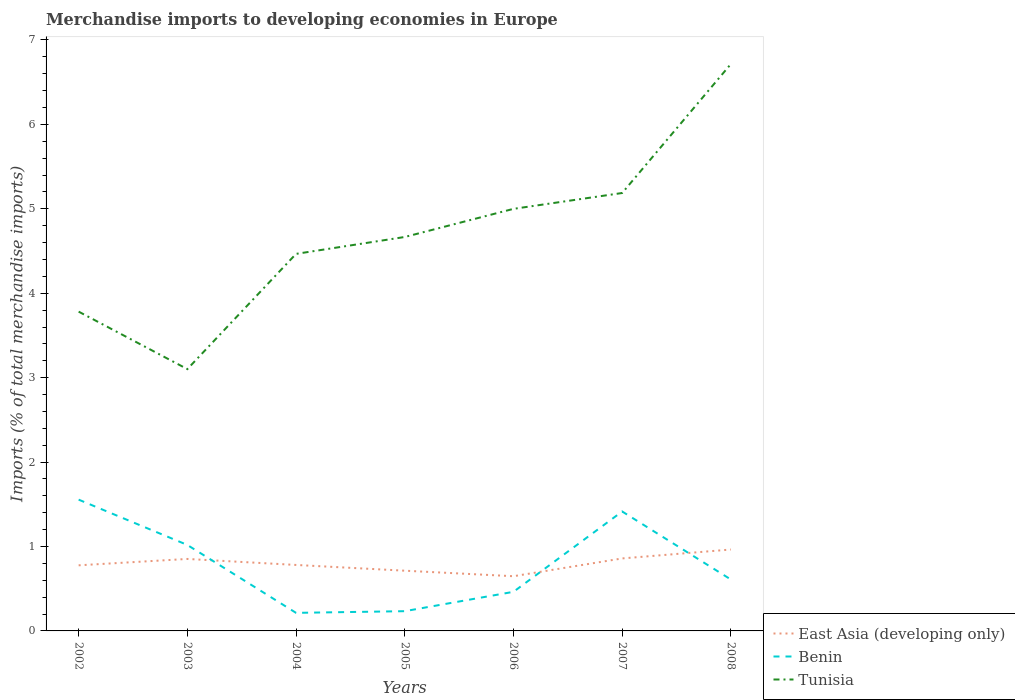How many different coloured lines are there?
Your answer should be compact. 3. Does the line corresponding to Benin intersect with the line corresponding to East Asia (developing only)?
Offer a very short reply. Yes. Is the number of lines equal to the number of legend labels?
Keep it short and to the point. Yes. Across all years, what is the maximum percentage total merchandise imports in Tunisia?
Provide a short and direct response. 3.1. In which year was the percentage total merchandise imports in East Asia (developing only) maximum?
Your answer should be compact. 2006. What is the total percentage total merchandise imports in Benin in the graph?
Provide a short and direct response. -0.23. What is the difference between the highest and the second highest percentage total merchandise imports in Tunisia?
Ensure brevity in your answer.  3.61. How many years are there in the graph?
Provide a short and direct response. 7. Does the graph contain any zero values?
Provide a short and direct response. No. Does the graph contain grids?
Provide a succinct answer. No. Where does the legend appear in the graph?
Provide a succinct answer. Bottom right. What is the title of the graph?
Provide a succinct answer. Merchandise imports to developing economies in Europe. What is the label or title of the X-axis?
Your answer should be compact. Years. What is the label or title of the Y-axis?
Your answer should be very brief. Imports (% of total merchandise imports). What is the Imports (% of total merchandise imports) of East Asia (developing only) in 2002?
Offer a terse response. 0.78. What is the Imports (% of total merchandise imports) of Benin in 2002?
Give a very brief answer. 1.56. What is the Imports (% of total merchandise imports) of Tunisia in 2002?
Your answer should be compact. 3.78. What is the Imports (% of total merchandise imports) of East Asia (developing only) in 2003?
Your answer should be very brief. 0.85. What is the Imports (% of total merchandise imports) in Benin in 2003?
Your answer should be compact. 1.02. What is the Imports (% of total merchandise imports) in Tunisia in 2003?
Your response must be concise. 3.1. What is the Imports (% of total merchandise imports) of East Asia (developing only) in 2004?
Make the answer very short. 0.78. What is the Imports (% of total merchandise imports) in Benin in 2004?
Your response must be concise. 0.21. What is the Imports (% of total merchandise imports) of Tunisia in 2004?
Your answer should be very brief. 4.47. What is the Imports (% of total merchandise imports) of East Asia (developing only) in 2005?
Your response must be concise. 0.71. What is the Imports (% of total merchandise imports) in Benin in 2005?
Keep it short and to the point. 0.23. What is the Imports (% of total merchandise imports) of Tunisia in 2005?
Provide a short and direct response. 4.67. What is the Imports (% of total merchandise imports) of East Asia (developing only) in 2006?
Provide a succinct answer. 0.65. What is the Imports (% of total merchandise imports) in Benin in 2006?
Provide a succinct answer. 0.46. What is the Imports (% of total merchandise imports) in Tunisia in 2006?
Your answer should be very brief. 5. What is the Imports (% of total merchandise imports) in East Asia (developing only) in 2007?
Your answer should be compact. 0.86. What is the Imports (% of total merchandise imports) of Benin in 2007?
Your answer should be compact. 1.41. What is the Imports (% of total merchandise imports) in Tunisia in 2007?
Provide a succinct answer. 5.19. What is the Imports (% of total merchandise imports) of East Asia (developing only) in 2008?
Offer a very short reply. 0.96. What is the Imports (% of total merchandise imports) of Benin in 2008?
Provide a succinct answer. 0.61. What is the Imports (% of total merchandise imports) of Tunisia in 2008?
Your answer should be very brief. 6.72. Across all years, what is the maximum Imports (% of total merchandise imports) of East Asia (developing only)?
Give a very brief answer. 0.96. Across all years, what is the maximum Imports (% of total merchandise imports) in Benin?
Your answer should be compact. 1.56. Across all years, what is the maximum Imports (% of total merchandise imports) in Tunisia?
Your answer should be compact. 6.72. Across all years, what is the minimum Imports (% of total merchandise imports) in East Asia (developing only)?
Keep it short and to the point. 0.65. Across all years, what is the minimum Imports (% of total merchandise imports) in Benin?
Provide a succinct answer. 0.21. Across all years, what is the minimum Imports (% of total merchandise imports) of Tunisia?
Make the answer very short. 3.1. What is the total Imports (% of total merchandise imports) of East Asia (developing only) in the graph?
Your response must be concise. 5.6. What is the total Imports (% of total merchandise imports) of Benin in the graph?
Your answer should be very brief. 5.51. What is the total Imports (% of total merchandise imports) of Tunisia in the graph?
Ensure brevity in your answer.  32.92. What is the difference between the Imports (% of total merchandise imports) in East Asia (developing only) in 2002 and that in 2003?
Your answer should be very brief. -0.08. What is the difference between the Imports (% of total merchandise imports) of Benin in 2002 and that in 2003?
Make the answer very short. 0.54. What is the difference between the Imports (% of total merchandise imports) in Tunisia in 2002 and that in 2003?
Give a very brief answer. 0.68. What is the difference between the Imports (% of total merchandise imports) of East Asia (developing only) in 2002 and that in 2004?
Provide a succinct answer. -0. What is the difference between the Imports (% of total merchandise imports) in Benin in 2002 and that in 2004?
Provide a succinct answer. 1.34. What is the difference between the Imports (% of total merchandise imports) of Tunisia in 2002 and that in 2004?
Provide a succinct answer. -0.68. What is the difference between the Imports (% of total merchandise imports) in East Asia (developing only) in 2002 and that in 2005?
Offer a terse response. 0.06. What is the difference between the Imports (% of total merchandise imports) in Benin in 2002 and that in 2005?
Give a very brief answer. 1.32. What is the difference between the Imports (% of total merchandise imports) in Tunisia in 2002 and that in 2005?
Offer a very short reply. -0.88. What is the difference between the Imports (% of total merchandise imports) of East Asia (developing only) in 2002 and that in 2006?
Provide a short and direct response. 0.13. What is the difference between the Imports (% of total merchandise imports) in Benin in 2002 and that in 2006?
Your answer should be compact. 1.09. What is the difference between the Imports (% of total merchandise imports) in Tunisia in 2002 and that in 2006?
Offer a very short reply. -1.22. What is the difference between the Imports (% of total merchandise imports) of East Asia (developing only) in 2002 and that in 2007?
Your answer should be compact. -0.08. What is the difference between the Imports (% of total merchandise imports) of Benin in 2002 and that in 2007?
Offer a terse response. 0.14. What is the difference between the Imports (% of total merchandise imports) of Tunisia in 2002 and that in 2007?
Ensure brevity in your answer.  -1.41. What is the difference between the Imports (% of total merchandise imports) in East Asia (developing only) in 2002 and that in 2008?
Make the answer very short. -0.19. What is the difference between the Imports (% of total merchandise imports) in Benin in 2002 and that in 2008?
Keep it short and to the point. 0.95. What is the difference between the Imports (% of total merchandise imports) in Tunisia in 2002 and that in 2008?
Provide a short and direct response. -2.93. What is the difference between the Imports (% of total merchandise imports) in East Asia (developing only) in 2003 and that in 2004?
Make the answer very short. 0.07. What is the difference between the Imports (% of total merchandise imports) in Benin in 2003 and that in 2004?
Provide a succinct answer. 0.8. What is the difference between the Imports (% of total merchandise imports) of Tunisia in 2003 and that in 2004?
Offer a very short reply. -1.37. What is the difference between the Imports (% of total merchandise imports) in East Asia (developing only) in 2003 and that in 2005?
Provide a succinct answer. 0.14. What is the difference between the Imports (% of total merchandise imports) in Benin in 2003 and that in 2005?
Make the answer very short. 0.78. What is the difference between the Imports (% of total merchandise imports) in Tunisia in 2003 and that in 2005?
Your answer should be very brief. -1.57. What is the difference between the Imports (% of total merchandise imports) of East Asia (developing only) in 2003 and that in 2006?
Your answer should be compact. 0.2. What is the difference between the Imports (% of total merchandise imports) in Benin in 2003 and that in 2006?
Provide a short and direct response. 0.56. What is the difference between the Imports (% of total merchandise imports) in Tunisia in 2003 and that in 2006?
Ensure brevity in your answer.  -1.9. What is the difference between the Imports (% of total merchandise imports) in East Asia (developing only) in 2003 and that in 2007?
Offer a very short reply. -0.01. What is the difference between the Imports (% of total merchandise imports) in Benin in 2003 and that in 2007?
Your response must be concise. -0.4. What is the difference between the Imports (% of total merchandise imports) of Tunisia in 2003 and that in 2007?
Keep it short and to the point. -2.09. What is the difference between the Imports (% of total merchandise imports) of East Asia (developing only) in 2003 and that in 2008?
Ensure brevity in your answer.  -0.11. What is the difference between the Imports (% of total merchandise imports) in Benin in 2003 and that in 2008?
Ensure brevity in your answer.  0.41. What is the difference between the Imports (% of total merchandise imports) of Tunisia in 2003 and that in 2008?
Your response must be concise. -3.61. What is the difference between the Imports (% of total merchandise imports) in East Asia (developing only) in 2004 and that in 2005?
Ensure brevity in your answer.  0.07. What is the difference between the Imports (% of total merchandise imports) of Benin in 2004 and that in 2005?
Provide a short and direct response. -0.02. What is the difference between the Imports (% of total merchandise imports) in East Asia (developing only) in 2004 and that in 2006?
Offer a very short reply. 0.13. What is the difference between the Imports (% of total merchandise imports) in Benin in 2004 and that in 2006?
Provide a succinct answer. -0.25. What is the difference between the Imports (% of total merchandise imports) of Tunisia in 2004 and that in 2006?
Offer a terse response. -0.53. What is the difference between the Imports (% of total merchandise imports) of East Asia (developing only) in 2004 and that in 2007?
Provide a short and direct response. -0.08. What is the difference between the Imports (% of total merchandise imports) of Benin in 2004 and that in 2007?
Ensure brevity in your answer.  -1.2. What is the difference between the Imports (% of total merchandise imports) of Tunisia in 2004 and that in 2007?
Offer a terse response. -0.72. What is the difference between the Imports (% of total merchandise imports) of East Asia (developing only) in 2004 and that in 2008?
Your response must be concise. -0.18. What is the difference between the Imports (% of total merchandise imports) in Benin in 2004 and that in 2008?
Provide a short and direct response. -0.4. What is the difference between the Imports (% of total merchandise imports) in Tunisia in 2004 and that in 2008?
Provide a succinct answer. -2.25. What is the difference between the Imports (% of total merchandise imports) of East Asia (developing only) in 2005 and that in 2006?
Give a very brief answer. 0.07. What is the difference between the Imports (% of total merchandise imports) of Benin in 2005 and that in 2006?
Make the answer very short. -0.23. What is the difference between the Imports (% of total merchandise imports) in Tunisia in 2005 and that in 2006?
Make the answer very short. -0.33. What is the difference between the Imports (% of total merchandise imports) of East Asia (developing only) in 2005 and that in 2007?
Offer a terse response. -0.15. What is the difference between the Imports (% of total merchandise imports) in Benin in 2005 and that in 2007?
Offer a terse response. -1.18. What is the difference between the Imports (% of total merchandise imports) of Tunisia in 2005 and that in 2007?
Your answer should be very brief. -0.52. What is the difference between the Imports (% of total merchandise imports) of East Asia (developing only) in 2005 and that in 2008?
Keep it short and to the point. -0.25. What is the difference between the Imports (% of total merchandise imports) of Benin in 2005 and that in 2008?
Keep it short and to the point. -0.38. What is the difference between the Imports (% of total merchandise imports) in Tunisia in 2005 and that in 2008?
Make the answer very short. -2.05. What is the difference between the Imports (% of total merchandise imports) of East Asia (developing only) in 2006 and that in 2007?
Your response must be concise. -0.21. What is the difference between the Imports (% of total merchandise imports) of Benin in 2006 and that in 2007?
Your response must be concise. -0.95. What is the difference between the Imports (% of total merchandise imports) in Tunisia in 2006 and that in 2007?
Make the answer very short. -0.19. What is the difference between the Imports (% of total merchandise imports) of East Asia (developing only) in 2006 and that in 2008?
Provide a succinct answer. -0.32. What is the difference between the Imports (% of total merchandise imports) in Benin in 2006 and that in 2008?
Your answer should be compact. -0.15. What is the difference between the Imports (% of total merchandise imports) in Tunisia in 2006 and that in 2008?
Make the answer very short. -1.72. What is the difference between the Imports (% of total merchandise imports) in East Asia (developing only) in 2007 and that in 2008?
Give a very brief answer. -0.11. What is the difference between the Imports (% of total merchandise imports) in Benin in 2007 and that in 2008?
Provide a succinct answer. 0.81. What is the difference between the Imports (% of total merchandise imports) of Tunisia in 2007 and that in 2008?
Ensure brevity in your answer.  -1.53. What is the difference between the Imports (% of total merchandise imports) in East Asia (developing only) in 2002 and the Imports (% of total merchandise imports) in Benin in 2003?
Your response must be concise. -0.24. What is the difference between the Imports (% of total merchandise imports) in East Asia (developing only) in 2002 and the Imports (% of total merchandise imports) in Tunisia in 2003?
Give a very brief answer. -2.32. What is the difference between the Imports (% of total merchandise imports) of Benin in 2002 and the Imports (% of total merchandise imports) of Tunisia in 2003?
Your response must be concise. -1.55. What is the difference between the Imports (% of total merchandise imports) of East Asia (developing only) in 2002 and the Imports (% of total merchandise imports) of Benin in 2004?
Ensure brevity in your answer.  0.56. What is the difference between the Imports (% of total merchandise imports) of East Asia (developing only) in 2002 and the Imports (% of total merchandise imports) of Tunisia in 2004?
Offer a very short reply. -3.69. What is the difference between the Imports (% of total merchandise imports) of Benin in 2002 and the Imports (% of total merchandise imports) of Tunisia in 2004?
Your answer should be very brief. -2.91. What is the difference between the Imports (% of total merchandise imports) in East Asia (developing only) in 2002 and the Imports (% of total merchandise imports) in Benin in 2005?
Provide a succinct answer. 0.54. What is the difference between the Imports (% of total merchandise imports) in East Asia (developing only) in 2002 and the Imports (% of total merchandise imports) in Tunisia in 2005?
Your answer should be compact. -3.89. What is the difference between the Imports (% of total merchandise imports) of Benin in 2002 and the Imports (% of total merchandise imports) of Tunisia in 2005?
Your answer should be compact. -3.11. What is the difference between the Imports (% of total merchandise imports) in East Asia (developing only) in 2002 and the Imports (% of total merchandise imports) in Benin in 2006?
Offer a terse response. 0.31. What is the difference between the Imports (% of total merchandise imports) of East Asia (developing only) in 2002 and the Imports (% of total merchandise imports) of Tunisia in 2006?
Give a very brief answer. -4.22. What is the difference between the Imports (% of total merchandise imports) in Benin in 2002 and the Imports (% of total merchandise imports) in Tunisia in 2006?
Your answer should be compact. -3.44. What is the difference between the Imports (% of total merchandise imports) in East Asia (developing only) in 2002 and the Imports (% of total merchandise imports) in Benin in 2007?
Your answer should be very brief. -0.64. What is the difference between the Imports (% of total merchandise imports) of East Asia (developing only) in 2002 and the Imports (% of total merchandise imports) of Tunisia in 2007?
Give a very brief answer. -4.41. What is the difference between the Imports (% of total merchandise imports) of Benin in 2002 and the Imports (% of total merchandise imports) of Tunisia in 2007?
Your response must be concise. -3.63. What is the difference between the Imports (% of total merchandise imports) in East Asia (developing only) in 2002 and the Imports (% of total merchandise imports) in Benin in 2008?
Your response must be concise. 0.17. What is the difference between the Imports (% of total merchandise imports) in East Asia (developing only) in 2002 and the Imports (% of total merchandise imports) in Tunisia in 2008?
Provide a short and direct response. -5.94. What is the difference between the Imports (% of total merchandise imports) in Benin in 2002 and the Imports (% of total merchandise imports) in Tunisia in 2008?
Offer a terse response. -5.16. What is the difference between the Imports (% of total merchandise imports) in East Asia (developing only) in 2003 and the Imports (% of total merchandise imports) in Benin in 2004?
Ensure brevity in your answer.  0.64. What is the difference between the Imports (% of total merchandise imports) of East Asia (developing only) in 2003 and the Imports (% of total merchandise imports) of Tunisia in 2004?
Your answer should be compact. -3.61. What is the difference between the Imports (% of total merchandise imports) in Benin in 2003 and the Imports (% of total merchandise imports) in Tunisia in 2004?
Offer a terse response. -3.45. What is the difference between the Imports (% of total merchandise imports) of East Asia (developing only) in 2003 and the Imports (% of total merchandise imports) of Benin in 2005?
Offer a terse response. 0.62. What is the difference between the Imports (% of total merchandise imports) in East Asia (developing only) in 2003 and the Imports (% of total merchandise imports) in Tunisia in 2005?
Your answer should be very brief. -3.81. What is the difference between the Imports (% of total merchandise imports) of Benin in 2003 and the Imports (% of total merchandise imports) of Tunisia in 2005?
Make the answer very short. -3.65. What is the difference between the Imports (% of total merchandise imports) of East Asia (developing only) in 2003 and the Imports (% of total merchandise imports) of Benin in 2006?
Ensure brevity in your answer.  0.39. What is the difference between the Imports (% of total merchandise imports) in East Asia (developing only) in 2003 and the Imports (% of total merchandise imports) in Tunisia in 2006?
Ensure brevity in your answer.  -4.15. What is the difference between the Imports (% of total merchandise imports) of Benin in 2003 and the Imports (% of total merchandise imports) of Tunisia in 2006?
Give a very brief answer. -3.98. What is the difference between the Imports (% of total merchandise imports) of East Asia (developing only) in 2003 and the Imports (% of total merchandise imports) of Benin in 2007?
Provide a short and direct response. -0.56. What is the difference between the Imports (% of total merchandise imports) in East Asia (developing only) in 2003 and the Imports (% of total merchandise imports) in Tunisia in 2007?
Ensure brevity in your answer.  -4.33. What is the difference between the Imports (% of total merchandise imports) of Benin in 2003 and the Imports (% of total merchandise imports) of Tunisia in 2007?
Give a very brief answer. -4.17. What is the difference between the Imports (% of total merchandise imports) of East Asia (developing only) in 2003 and the Imports (% of total merchandise imports) of Benin in 2008?
Offer a terse response. 0.24. What is the difference between the Imports (% of total merchandise imports) in East Asia (developing only) in 2003 and the Imports (% of total merchandise imports) in Tunisia in 2008?
Offer a terse response. -5.86. What is the difference between the Imports (% of total merchandise imports) of Benin in 2003 and the Imports (% of total merchandise imports) of Tunisia in 2008?
Make the answer very short. -5.7. What is the difference between the Imports (% of total merchandise imports) in East Asia (developing only) in 2004 and the Imports (% of total merchandise imports) in Benin in 2005?
Your answer should be very brief. 0.55. What is the difference between the Imports (% of total merchandise imports) of East Asia (developing only) in 2004 and the Imports (% of total merchandise imports) of Tunisia in 2005?
Offer a very short reply. -3.88. What is the difference between the Imports (% of total merchandise imports) of Benin in 2004 and the Imports (% of total merchandise imports) of Tunisia in 2005?
Keep it short and to the point. -4.45. What is the difference between the Imports (% of total merchandise imports) of East Asia (developing only) in 2004 and the Imports (% of total merchandise imports) of Benin in 2006?
Offer a terse response. 0.32. What is the difference between the Imports (% of total merchandise imports) of East Asia (developing only) in 2004 and the Imports (% of total merchandise imports) of Tunisia in 2006?
Offer a terse response. -4.22. What is the difference between the Imports (% of total merchandise imports) of Benin in 2004 and the Imports (% of total merchandise imports) of Tunisia in 2006?
Provide a succinct answer. -4.79. What is the difference between the Imports (% of total merchandise imports) of East Asia (developing only) in 2004 and the Imports (% of total merchandise imports) of Benin in 2007?
Keep it short and to the point. -0.63. What is the difference between the Imports (% of total merchandise imports) in East Asia (developing only) in 2004 and the Imports (% of total merchandise imports) in Tunisia in 2007?
Give a very brief answer. -4.41. What is the difference between the Imports (% of total merchandise imports) in Benin in 2004 and the Imports (% of total merchandise imports) in Tunisia in 2007?
Your answer should be very brief. -4.97. What is the difference between the Imports (% of total merchandise imports) in East Asia (developing only) in 2004 and the Imports (% of total merchandise imports) in Benin in 2008?
Offer a terse response. 0.17. What is the difference between the Imports (% of total merchandise imports) in East Asia (developing only) in 2004 and the Imports (% of total merchandise imports) in Tunisia in 2008?
Your response must be concise. -5.93. What is the difference between the Imports (% of total merchandise imports) of Benin in 2004 and the Imports (% of total merchandise imports) of Tunisia in 2008?
Your response must be concise. -6.5. What is the difference between the Imports (% of total merchandise imports) of East Asia (developing only) in 2005 and the Imports (% of total merchandise imports) of Benin in 2006?
Offer a very short reply. 0.25. What is the difference between the Imports (% of total merchandise imports) of East Asia (developing only) in 2005 and the Imports (% of total merchandise imports) of Tunisia in 2006?
Ensure brevity in your answer.  -4.29. What is the difference between the Imports (% of total merchandise imports) in Benin in 2005 and the Imports (% of total merchandise imports) in Tunisia in 2006?
Keep it short and to the point. -4.77. What is the difference between the Imports (% of total merchandise imports) of East Asia (developing only) in 2005 and the Imports (% of total merchandise imports) of Benin in 2007?
Keep it short and to the point. -0.7. What is the difference between the Imports (% of total merchandise imports) in East Asia (developing only) in 2005 and the Imports (% of total merchandise imports) in Tunisia in 2007?
Provide a succinct answer. -4.47. What is the difference between the Imports (% of total merchandise imports) in Benin in 2005 and the Imports (% of total merchandise imports) in Tunisia in 2007?
Your answer should be very brief. -4.95. What is the difference between the Imports (% of total merchandise imports) of East Asia (developing only) in 2005 and the Imports (% of total merchandise imports) of Benin in 2008?
Offer a terse response. 0.1. What is the difference between the Imports (% of total merchandise imports) in East Asia (developing only) in 2005 and the Imports (% of total merchandise imports) in Tunisia in 2008?
Keep it short and to the point. -6. What is the difference between the Imports (% of total merchandise imports) in Benin in 2005 and the Imports (% of total merchandise imports) in Tunisia in 2008?
Give a very brief answer. -6.48. What is the difference between the Imports (% of total merchandise imports) of East Asia (developing only) in 2006 and the Imports (% of total merchandise imports) of Benin in 2007?
Your response must be concise. -0.77. What is the difference between the Imports (% of total merchandise imports) in East Asia (developing only) in 2006 and the Imports (% of total merchandise imports) in Tunisia in 2007?
Your answer should be very brief. -4.54. What is the difference between the Imports (% of total merchandise imports) in Benin in 2006 and the Imports (% of total merchandise imports) in Tunisia in 2007?
Your answer should be compact. -4.72. What is the difference between the Imports (% of total merchandise imports) of East Asia (developing only) in 2006 and the Imports (% of total merchandise imports) of Benin in 2008?
Provide a short and direct response. 0.04. What is the difference between the Imports (% of total merchandise imports) of East Asia (developing only) in 2006 and the Imports (% of total merchandise imports) of Tunisia in 2008?
Offer a very short reply. -6.07. What is the difference between the Imports (% of total merchandise imports) in Benin in 2006 and the Imports (% of total merchandise imports) in Tunisia in 2008?
Offer a terse response. -6.25. What is the difference between the Imports (% of total merchandise imports) in East Asia (developing only) in 2007 and the Imports (% of total merchandise imports) in Benin in 2008?
Your answer should be very brief. 0.25. What is the difference between the Imports (% of total merchandise imports) of East Asia (developing only) in 2007 and the Imports (% of total merchandise imports) of Tunisia in 2008?
Offer a very short reply. -5.86. What is the difference between the Imports (% of total merchandise imports) in Benin in 2007 and the Imports (% of total merchandise imports) in Tunisia in 2008?
Keep it short and to the point. -5.3. What is the average Imports (% of total merchandise imports) of East Asia (developing only) per year?
Provide a short and direct response. 0.8. What is the average Imports (% of total merchandise imports) of Benin per year?
Keep it short and to the point. 0.79. What is the average Imports (% of total merchandise imports) in Tunisia per year?
Offer a terse response. 4.7. In the year 2002, what is the difference between the Imports (% of total merchandise imports) in East Asia (developing only) and Imports (% of total merchandise imports) in Benin?
Your answer should be compact. -0.78. In the year 2002, what is the difference between the Imports (% of total merchandise imports) in East Asia (developing only) and Imports (% of total merchandise imports) in Tunisia?
Provide a short and direct response. -3. In the year 2002, what is the difference between the Imports (% of total merchandise imports) of Benin and Imports (% of total merchandise imports) of Tunisia?
Your response must be concise. -2.23. In the year 2003, what is the difference between the Imports (% of total merchandise imports) in East Asia (developing only) and Imports (% of total merchandise imports) in Benin?
Provide a succinct answer. -0.17. In the year 2003, what is the difference between the Imports (% of total merchandise imports) in East Asia (developing only) and Imports (% of total merchandise imports) in Tunisia?
Provide a short and direct response. -2.25. In the year 2003, what is the difference between the Imports (% of total merchandise imports) of Benin and Imports (% of total merchandise imports) of Tunisia?
Make the answer very short. -2.08. In the year 2004, what is the difference between the Imports (% of total merchandise imports) of East Asia (developing only) and Imports (% of total merchandise imports) of Benin?
Make the answer very short. 0.57. In the year 2004, what is the difference between the Imports (% of total merchandise imports) in East Asia (developing only) and Imports (% of total merchandise imports) in Tunisia?
Provide a short and direct response. -3.68. In the year 2004, what is the difference between the Imports (% of total merchandise imports) in Benin and Imports (% of total merchandise imports) in Tunisia?
Keep it short and to the point. -4.25. In the year 2005, what is the difference between the Imports (% of total merchandise imports) in East Asia (developing only) and Imports (% of total merchandise imports) in Benin?
Your answer should be very brief. 0.48. In the year 2005, what is the difference between the Imports (% of total merchandise imports) of East Asia (developing only) and Imports (% of total merchandise imports) of Tunisia?
Offer a very short reply. -3.95. In the year 2005, what is the difference between the Imports (% of total merchandise imports) in Benin and Imports (% of total merchandise imports) in Tunisia?
Your answer should be very brief. -4.43. In the year 2006, what is the difference between the Imports (% of total merchandise imports) of East Asia (developing only) and Imports (% of total merchandise imports) of Benin?
Your response must be concise. 0.18. In the year 2006, what is the difference between the Imports (% of total merchandise imports) of East Asia (developing only) and Imports (% of total merchandise imports) of Tunisia?
Your answer should be very brief. -4.35. In the year 2006, what is the difference between the Imports (% of total merchandise imports) of Benin and Imports (% of total merchandise imports) of Tunisia?
Offer a terse response. -4.54. In the year 2007, what is the difference between the Imports (% of total merchandise imports) of East Asia (developing only) and Imports (% of total merchandise imports) of Benin?
Ensure brevity in your answer.  -0.56. In the year 2007, what is the difference between the Imports (% of total merchandise imports) of East Asia (developing only) and Imports (% of total merchandise imports) of Tunisia?
Provide a succinct answer. -4.33. In the year 2007, what is the difference between the Imports (% of total merchandise imports) of Benin and Imports (% of total merchandise imports) of Tunisia?
Ensure brevity in your answer.  -3.77. In the year 2008, what is the difference between the Imports (% of total merchandise imports) in East Asia (developing only) and Imports (% of total merchandise imports) in Benin?
Keep it short and to the point. 0.36. In the year 2008, what is the difference between the Imports (% of total merchandise imports) of East Asia (developing only) and Imports (% of total merchandise imports) of Tunisia?
Offer a very short reply. -5.75. In the year 2008, what is the difference between the Imports (% of total merchandise imports) of Benin and Imports (% of total merchandise imports) of Tunisia?
Keep it short and to the point. -6.11. What is the ratio of the Imports (% of total merchandise imports) in East Asia (developing only) in 2002 to that in 2003?
Ensure brevity in your answer.  0.91. What is the ratio of the Imports (% of total merchandise imports) of Benin in 2002 to that in 2003?
Provide a succinct answer. 1.53. What is the ratio of the Imports (% of total merchandise imports) in Tunisia in 2002 to that in 2003?
Your answer should be very brief. 1.22. What is the ratio of the Imports (% of total merchandise imports) in East Asia (developing only) in 2002 to that in 2004?
Your answer should be compact. 0.99. What is the ratio of the Imports (% of total merchandise imports) of Benin in 2002 to that in 2004?
Your answer should be compact. 7.27. What is the ratio of the Imports (% of total merchandise imports) of Tunisia in 2002 to that in 2004?
Your response must be concise. 0.85. What is the ratio of the Imports (% of total merchandise imports) in East Asia (developing only) in 2002 to that in 2005?
Keep it short and to the point. 1.09. What is the ratio of the Imports (% of total merchandise imports) of Benin in 2002 to that in 2005?
Keep it short and to the point. 6.65. What is the ratio of the Imports (% of total merchandise imports) in Tunisia in 2002 to that in 2005?
Provide a succinct answer. 0.81. What is the ratio of the Imports (% of total merchandise imports) of East Asia (developing only) in 2002 to that in 2006?
Offer a terse response. 1.2. What is the ratio of the Imports (% of total merchandise imports) of Benin in 2002 to that in 2006?
Provide a short and direct response. 3.36. What is the ratio of the Imports (% of total merchandise imports) of Tunisia in 2002 to that in 2006?
Your answer should be very brief. 0.76. What is the ratio of the Imports (% of total merchandise imports) of East Asia (developing only) in 2002 to that in 2007?
Your answer should be compact. 0.91. What is the ratio of the Imports (% of total merchandise imports) in Benin in 2002 to that in 2007?
Offer a terse response. 1.1. What is the ratio of the Imports (% of total merchandise imports) of Tunisia in 2002 to that in 2007?
Your response must be concise. 0.73. What is the ratio of the Imports (% of total merchandise imports) in East Asia (developing only) in 2002 to that in 2008?
Make the answer very short. 0.81. What is the ratio of the Imports (% of total merchandise imports) in Benin in 2002 to that in 2008?
Keep it short and to the point. 2.55. What is the ratio of the Imports (% of total merchandise imports) of Tunisia in 2002 to that in 2008?
Provide a short and direct response. 0.56. What is the ratio of the Imports (% of total merchandise imports) in East Asia (developing only) in 2003 to that in 2004?
Make the answer very short. 1.09. What is the ratio of the Imports (% of total merchandise imports) of Benin in 2003 to that in 2004?
Your answer should be very brief. 4.76. What is the ratio of the Imports (% of total merchandise imports) of Tunisia in 2003 to that in 2004?
Give a very brief answer. 0.69. What is the ratio of the Imports (% of total merchandise imports) of East Asia (developing only) in 2003 to that in 2005?
Offer a very short reply. 1.2. What is the ratio of the Imports (% of total merchandise imports) in Benin in 2003 to that in 2005?
Your answer should be very brief. 4.35. What is the ratio of the Imports (% of total merchandise imports) of Tunisia in 2003 to that in 2005?
Your answer should be very brief. 0.66. What is the ratio of the Imports (% of total merchandise imports) in East Asia (developing only) in 2003 to that in 2006?
Provide a short and direct response. 1.32. What is the ratio of the Imports (% of total merchandise imports) of Benin in 2003 to that in 2006?
Your answer should be compact. 2.2. What is the ratio of the Imports (% of total merchandise imports) of Tunisia in 2003 to that in 2006?
Provide a succinct answer. 0.62. What is the ratio of the Imports (% of total merchandise imports) of Benin in 2003 to that in 2007?
Provide a succinct answer. 0.72. What is the ratio of the Imports (% of total merchandise imports) in Tunisia in 2003 to that in 2007?
Your response must be concise. 0.6. What is the ratio of the Imports (% of total merchandise imports) of East Asia (developing only) in 2003 to that in 2008?
Make the answer very short. 0.88. What is the ratio of the Imports (% of total merchandise imports) of Benin in 2003 to that in 2008?
Ensure brevity in your answer.  1.67. What is the ratio of the Imports (% of total merchandise imports) of Tunisia in 2003 to that in 2008?
Keep it short and to the point. 0.46. What is the ratio of the Imports (% of total merchandise imports) of East Asia (developing only) in 2004 to that in 2005?
Make the answer very short. 1.1. What is the ratio of the Imports (% of total merchandise imports) of Benin in 2004 to that in 2005?
Keep it short and to the point. 0.91. What is the ratio of the Imports (% of total merchandise imports) of Tunisia in 2004 to that in 2005?
Your answer should be very brief. 0.96. What is the ratio of the Imports (% of total merchandise imports) of East Asia (developing only) in 2004 to that in 2006?
Give a very brief answer. 1.21. What is the ratio of the Imports (% of total merchandise imports) in Benin in 2004 to that in 2006?
Keep it short and to the point. 0.46. What is the ratio of the Imports (% of total merchandise imports) in Tunisia in 2004 to that in 2006?
Offer a very short reply. 0.89. What is the ratio of the Imports (% of total merchandise imports) in East Asia (developing only) in 2004 to that in 2007?
Provide a succinct answer. 0.91. What is the ratio of the Imports (% of total merchandise imports) in Benin in 2004 to that in 2007?
Give a very brief answer. 0.15. What is the ratio of the Imports (% of total merchandise imports) in Tunisia in 2004 to that in 2007?
Offer a terse response. 0.86. What is the ratio of the Imports (% of total merchandise imports) of East Asia (developing only) in 2004 to that in 2008?
Your answer should be very brief. 0.81. What is the ratio of the Imports (% of total merchandise imports) of Benin in 2004 to that in 2008?
Your answer should be very brief. 0.35. What is the ratio of the Imports (% of total merchandise imports) in Tunisia in 2004 to that in 2008?
Your answer should be compact. 0.67. What is the ratio of the Imports (% of total merchandise imports) of East Asia (developing only) in 2005 to that in 2006?
Offer a very short reply. 1.1. What is the ratio of the Imports (% of total merchandise imports) in Benin in 2005 to that in 2006?
Keep it short and to the point. 0.51. What is the ratio of the Imports (% of total merchandise imports) of Tunisia in 2005 to that in 2006?
Provide a succinct answer. 0.93. What is the ratio of the Imports (% of total merchandise imports) of East Asia (developing only) in 2005 to that in 2007?
Make the answer very short. 0.83. What is the ratio of the Imports (% of total merchandise imports) in Benin in 2005 to that in 2007?
Offer a terse response. 0.17. What is the ratio of the Imports (% of total merchandise imports) of Tunisia in 2005 to that in 2007?
Provide a short and direct response. 0.9. What is the ratio of the Imports (% of total merchandise imports) in East Asia (developing only) in 2005 to that in 2008?
Offer a very short reply. 0.74. What is the ratio of the Imports (% of total merchandise imports) in Benin in 2005 to that in 2008?
Your answer should be compact. 0.38. What is the ratio of the Imports (% of total merchandise imports) of Tunisia in 2005 to that in 2008?
Ensure brevity in your answer.  0.69. What is the ratio of the Imports (% of total merchandise imports) in East Asia (developing only) in 2006 to that in 2007?
Make the answer very short. 0.75. What is the ratio of the Imports (% of total merchandise imports) in Benin in 2006 to that in 2007?
Offer a terse response. 0.33. What is the ratio of the Imports (% of total merchandise imports) in Tunisia in 2006 to that in 2007?
Your answer should be very brief. 0.96. What is the ratio of the Imports (% of total merchandise imports) of East Asia (developing only) in 2006 to that in 2008?
Provide a succinct answer. 0.67. What is the ratio of the Imports (% of total merchandise imports) of Benin in 2006 to that in 2008?
Offer a terse response. 0.76. What is the ratio of the Imports (% of total merchandise imports) in Tunisia in 2006 to that in 2008?
Give a very brief answer. 0.74. What is the ratio of the Imports (% of total merchandise imports) of East Asia (developing only) in 2007 to that in 2008?
Provide a succinct answer. 0.89. What is the ratio of the Imports (% of total merchandise imports) of Benin in 2007 to that in 2008?
Give a very brief answer. 2.32. What is the ratio of the Imports (% of total merchandise imports) in Tunisia in 2007 to that in 2008?
Offer a very short reply. 0.77. What is the difference between the highest and the second highest Imports (% of total merchandise imports) of East Asia (developing only)?
Provide a short and direct response. 0.11. What is the difference between the highest and the second highest Imports (% of total merchandise imports) of Benin?
Keep it short and to the point. 0.14. What is the difference between the highest and the second highest Imports (% of total merchandise imports) in Tunisia?
Offer a terse response. 1.53. What is the difference between the highest and the lowest Imports (% of total merchandise imports) of East Asia (developing only)?
Give a very brief answer. 0.32. What is the difference between the highest and the lowest Imports (% of total merchandise imports) in Benin?
Provide a short and direct response. 1.34. What is the difference between the highest and the lowest Imports (% of total merchandise imports) of Tunisia?
Keep it short and to the point. 3.61. 